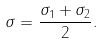<formula> <loc_0><loc_0><loc_500><loc_500>\sigma = \frac { \sigma _ { 1 } + \sigma _ { 2 } } { 2 } .</formula> 